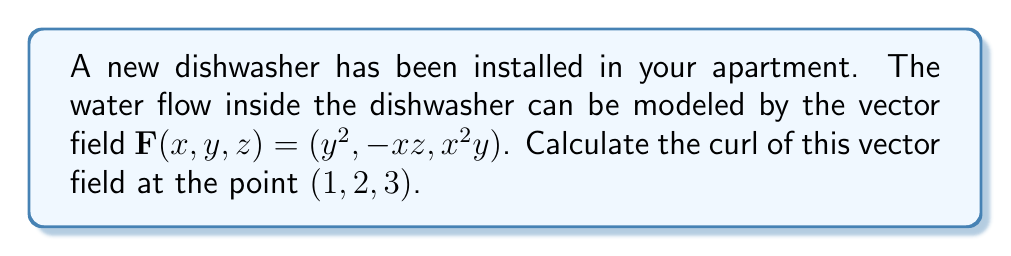Can you solve this math problem? Let's approach this step-by-step:

1) The curl of a vector field $\mathbf{F}(x,y,z) = (F_1, F_2, F_3)$ is defined as:

   $$\text{curl }\mathbf{F} = \nabla \times \mathbf{F} = \left(\frac{\partial F_3}{\partial y} - \frac{\partial F_2}{\partial z}, \frac{\partial F_1}{\partial z} - \frac{\partial F_3}{\partial x}, \frac{\partial F_2}{\partial x} - \frac{\partial F_1}{\partial y}\right)$$

2) In our case, $F_1 = y^2$, $F_2 = -xz$, and $F_3 = x^2y$

3) Let's calculate each component:

   a) $\frac{\partial F_3}{\partial y} - \frac{\partial F_2}{\partial z}$:
      $\frac{\partial}{\partial y}(x^2y) - \frac{\partial}{\partial z}(-xz) = x^2 - (-x) = x^2 + x$

   b) $\frac{\partial F_1}{\partial z} - \frac{\partial F_3}{\partial x}$:
      $\frac{\partial}{\partial z}(y^2) - \frac{\partial}{\partial x}(x^2y) = 0 - (2xy) = -2xy$

   c) $\frac{\partial F_2}{\partial x} - \frac{\partial F_1}{\partial y}$:
      $\frac{\partial}{\partial x}(-xz) - \frac{\partial}{\partial y}(y^2) = -z - 2y$

4) Therefore, $\text{curl }\mathbf{F} = (x^2 + x, -2xy, -z - 2y)$

5) At the point $(1, 2, 3)$, we have:
   $$(1^2 + 1, -2(1)(2), -3 - 2(2)) = (2, -4, -7)$$
Answer: $(2, -4, -7)$ 